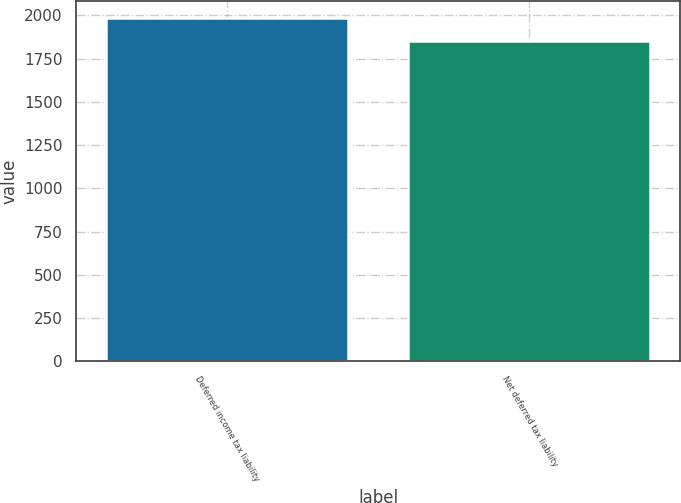Convert chart. <chart><loc_0><loc_0><loc_500><loc_500><bar_chart><fcel>Deferred income tax liability<fcel>Net deferred tax liability<nl><fcel>1984<fcel>1853<nl></chart> 